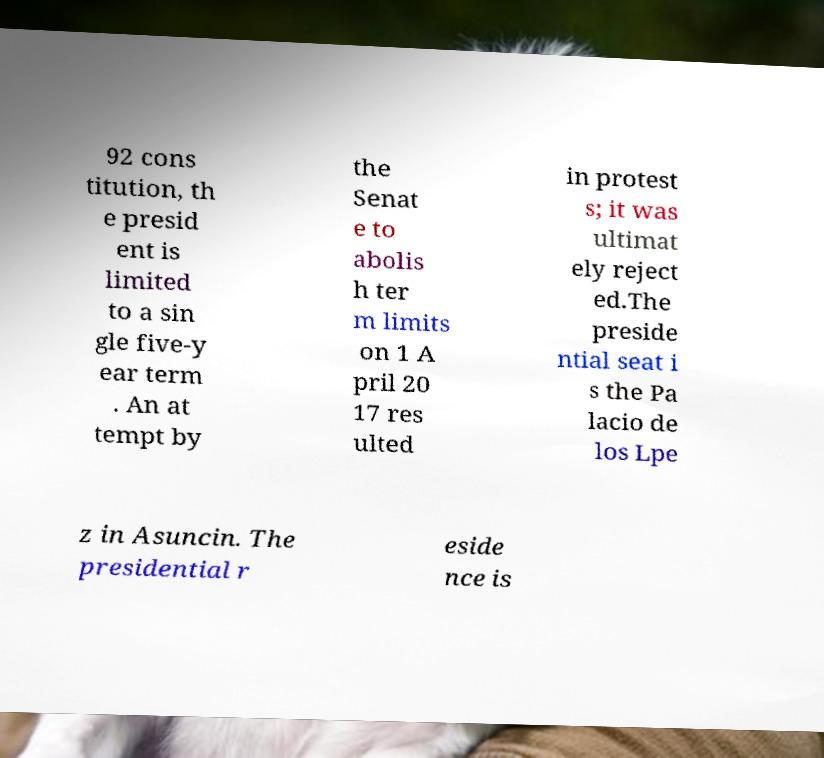Could you extract and type out the text from this image? 92 cons titution, th e presid ent is limited to a sin gle five-y ear term . An at tempt by the Senat e to abolis h ter m limits on 1 A pril 20 17 res ulted in protest s; it was ultimat ely reject ed.The preside ntial seat i s the Pa lacio de los Lpe z in Asuncin. The presidential r eside nce is 